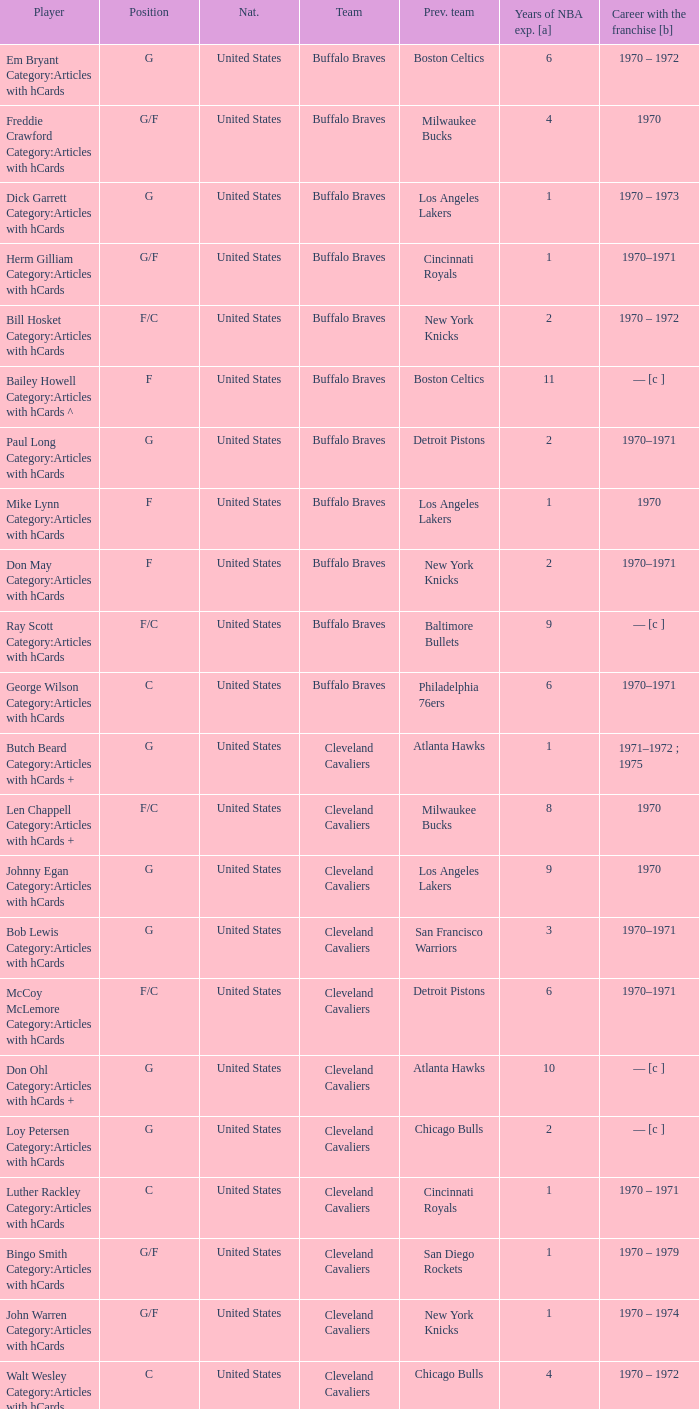How many years of NBA experience does the player who plays position g for the Portland Trail Blazers? 2.0. 